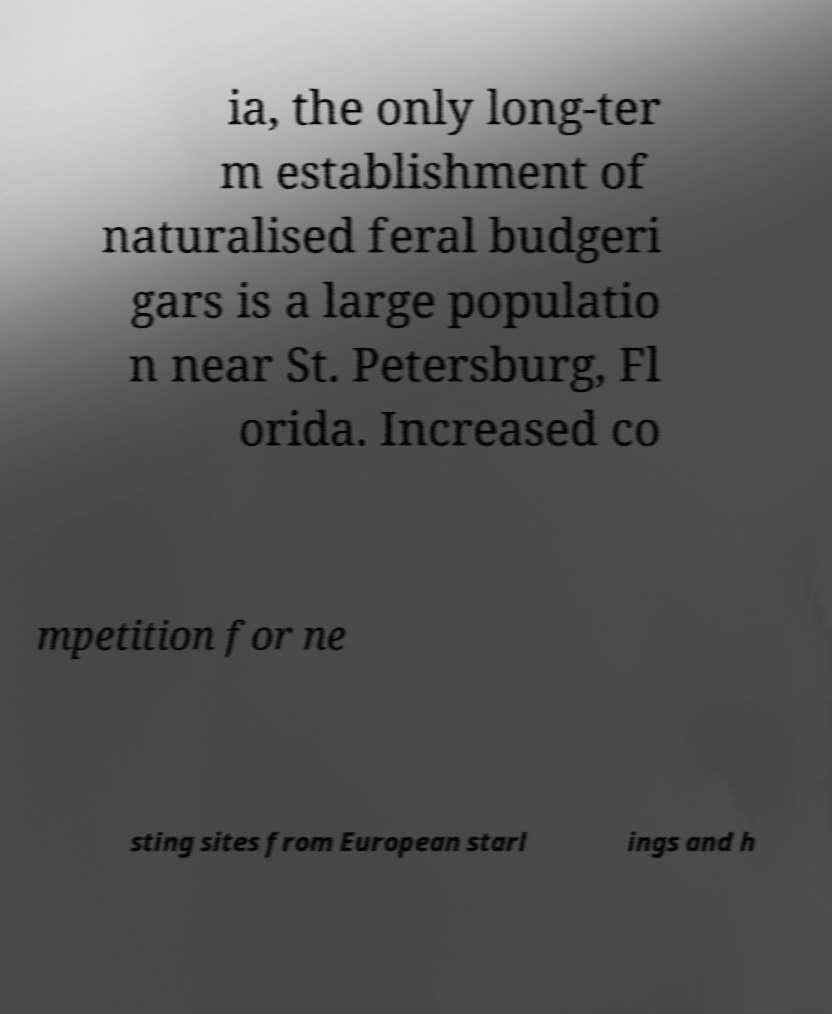Could you assist in decoding the text presented in this image and type it out clearly? ia, the only long-ter m establishment of naturalised feral budgeri gars is a large populatio n near St. Petersburg, Fl orida. Increased co mpetition for ne sting sites from European starl ings and h 